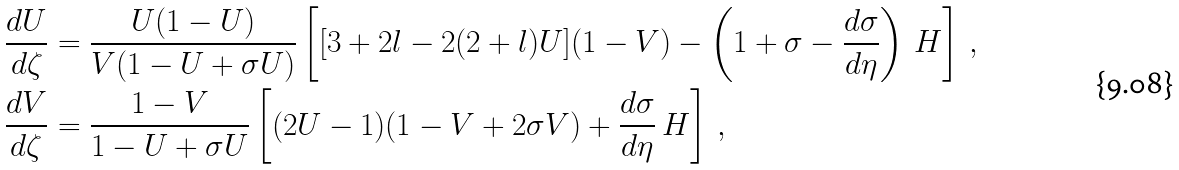<formula> <loc_0><loc_0><loc_500><loc_500>\frac { d U } { d \zeta } & = \frac { U ( 1 - U ) } { V ( 1 - U + \sigma U ) } \left [ [ 3 + 2 l - 2 ( 2 + l ) U ] ( 1 - V ) - \left ( 1 + \sigma - \frac { d \sigma } { d \eta } \right ) \, H \right ] \, , \\ \frac { d V } { d \zeta } & = \frac { 1 - V } { 1 - U + \sigma U } \left [ ( 2 U - 1 ) ( 1 - V + 2 \sigma V ) + \frac { d \sigma } { d \eta } \, H \right ] \, ,</formula> 